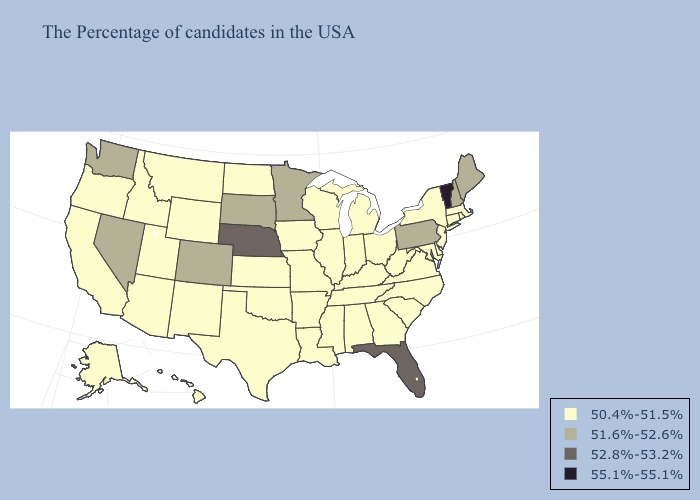Name the states that have a value in the range 50.4%-51.5%?
Be succinct. Massachusetts, Rhode Island, Connecticut, New York, New Jersey, Delaware, Maryland, Virginia, North Carolina, South Carolina, West Virginia, Ohio, Georgia, Michigan, Kentucky, Indiana, Alabama, Tennessee, Wisconsin, Illinois, Mississippi, Louisiana, Missouri, Arkansas, Iowa, Kansas, Oklahoma, Texas, North Dakota, Wyoming, New Mexico, Utah, Montana, Arizona, Idaho, California, Oregon, Alaska, Hawaii. Name the states that have a value in the range 55.1%-55.1%?
Give a very brief answer. Vermont. Name the states that have a value in the range 55.1%-55.1%?
Give a very brief answer. Vermont. Does Montana have a higher value than Illinois?
Write a very short answer. No. What is the value of Louisiana?
Give a very brief answer. 50.4%-51.5%. Name the states that have a value in the range 50.4%-51.5%?
Short answer required. Massachusetts, Rhode Island, Connecticut, New York, New Jersey, Delaware, Maryland, Virginia, North Carolina, South Carolina, West Virginia, Ohio, Georgia, Michigan, Kentucky, Indiana, Alabama, Tennessee, Wisconsin, Illinois, Mississippi, Louisiana, Missouri, Arkansas, Iowa, Kansas, Oklahoma, Texas, North Dakota, Wyoming, New Mexico, Utah, Montana, Arizona, Idaho, California, Oregon, Alaska, Hawaii. What is the value of Nevada?
Give a very brief answer. 51.6%-52.6%. Does the map have missing data?
Short answer required. No. What is the value of Idaho?
Write a very short answer. 50.4%-51.5%. Name the states that have a value in the range 55.1%-55.1%?
Short answer required. Vermont. Among the states that border Connecticut , which have the lowest value?
Be succinct. Massachusetts, Rhode Island, New York. What is the value of Pennsylvania?
Be succinct. 51.6%-52.6%. Does Washington have the highest value in the West?
Be succinct. Yes. How many symbols are there in the legend?
Give a very brief answer. 4. Does the first symbol in the legend represent the smallest category?
Keep it brief. Yes. 